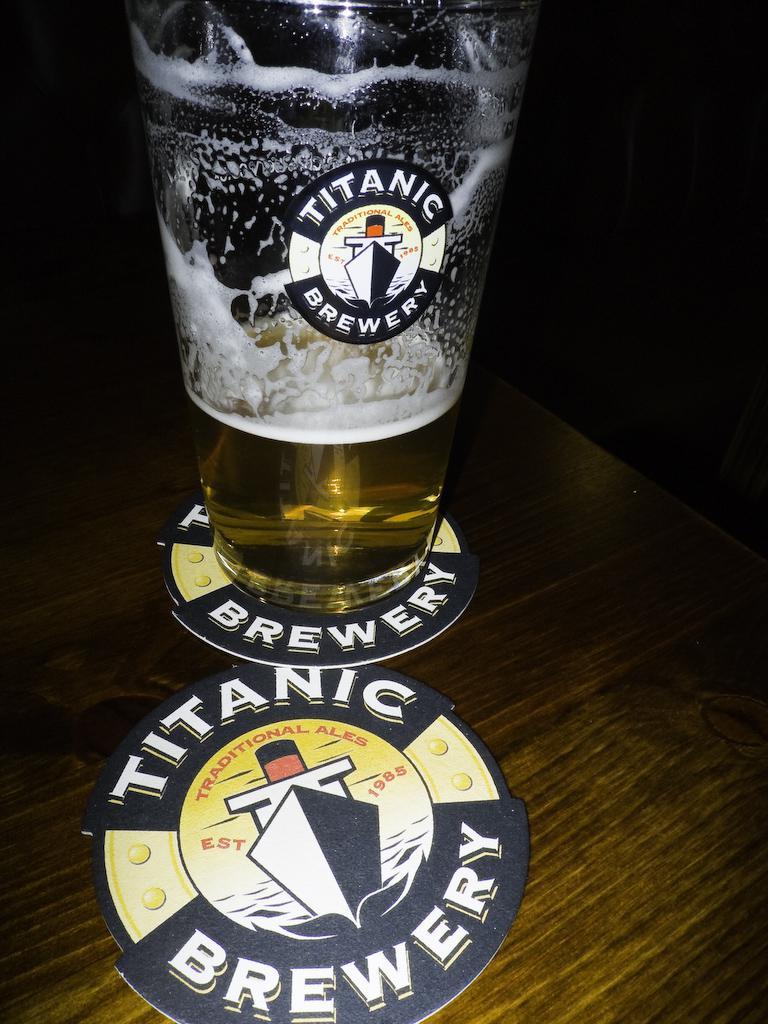What brewery is featured?
Ensure brevity in your answer.  Titanic. What type of ales does this brewery make?
Ensure brevity in your answer.  Traditional. 